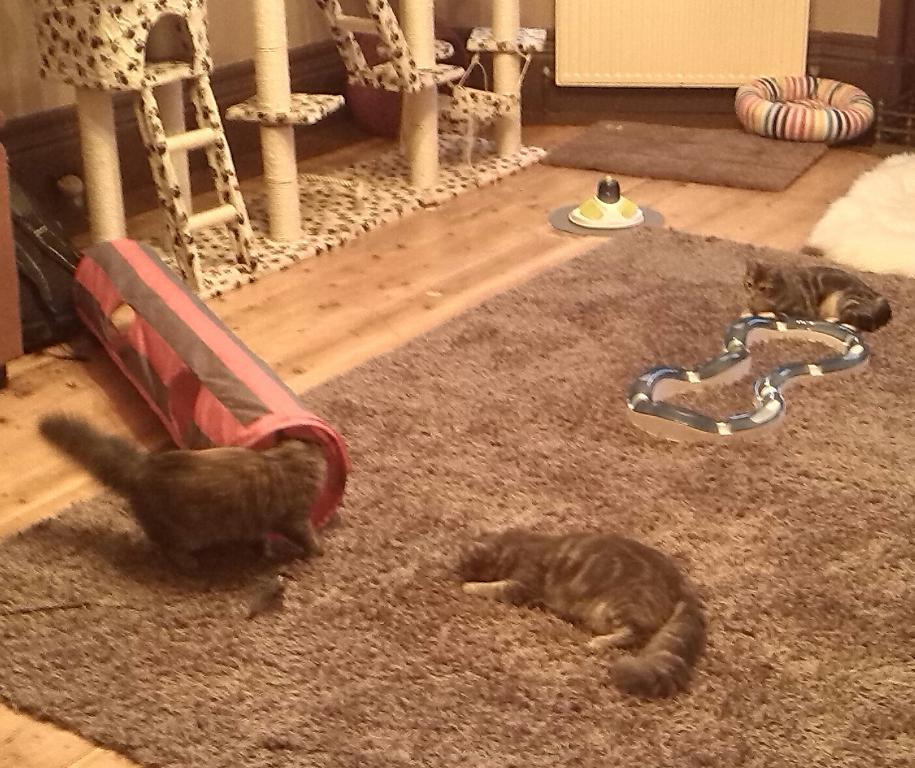How many cats are in the image? There are three cats in the image. Where are the cats located? The cats are on a carpet in the image. What furniture is present in the image? There is a pet bed in the image. What type of flooring is visible in the image? There are mats in the image. Are there any other structures or objects in the image? Yes, there are ladders in the image. Can you describe the unspecified objects in the image? Unfortunately, the facts provided do not specify the nature of the unspecified objects. What type of alley can be seen in the image? There is no alley present in the image. What smell is emanating from the cats in the image? The facts provided do not mention any smells associated with the cats or the image. 